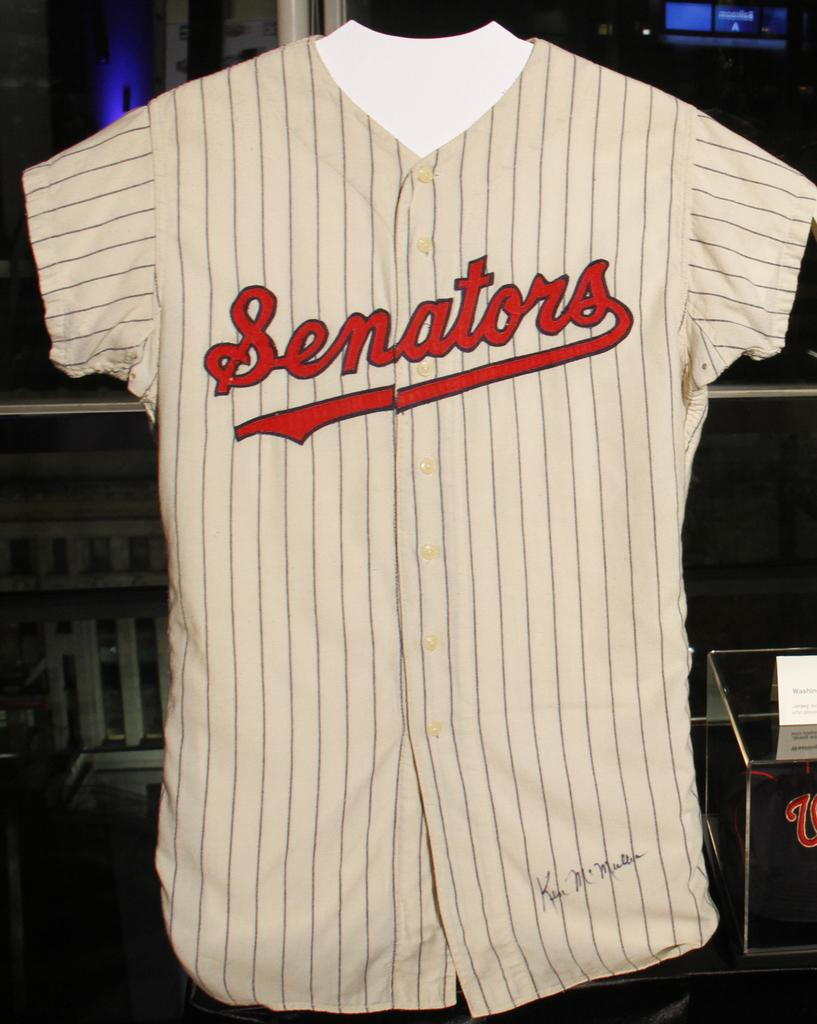<image>
Render a clear and concise summary of the photo. the signed baseball jersey is for team Senators 